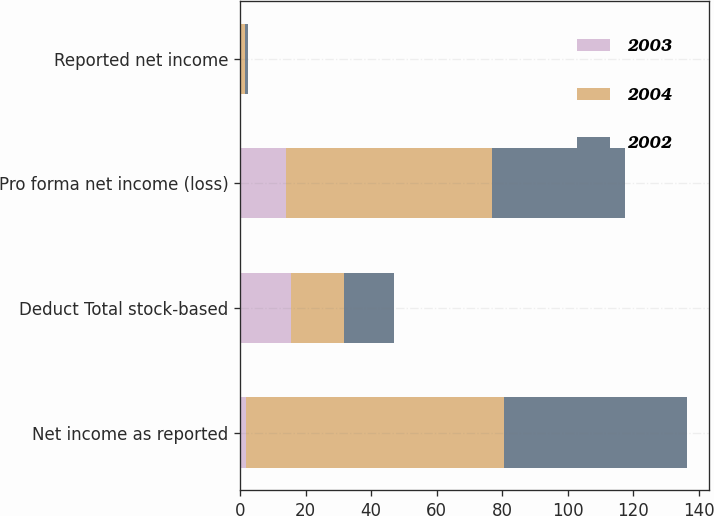Convert chart. <chart><loc_0><loc_0><loc_500><loc_500><stacked_bar_chart><ecel><fcel>Net income as reported<fcel>Deduct Total stock-based<fcel>Pro forma net income (loss)<fcel>Reported net income<nl><fcel>2003<fcel>1.7<fcel>15.7<fcel>14<fcel>0.03<nl><fcel>2004<fcel>79<fcel>16<fcel>63<fcel>1.34<nl><fcel>2002<fcel>55.7<fcel>15.3<fcel>40.4<fcel>0.94<nl></chart> 